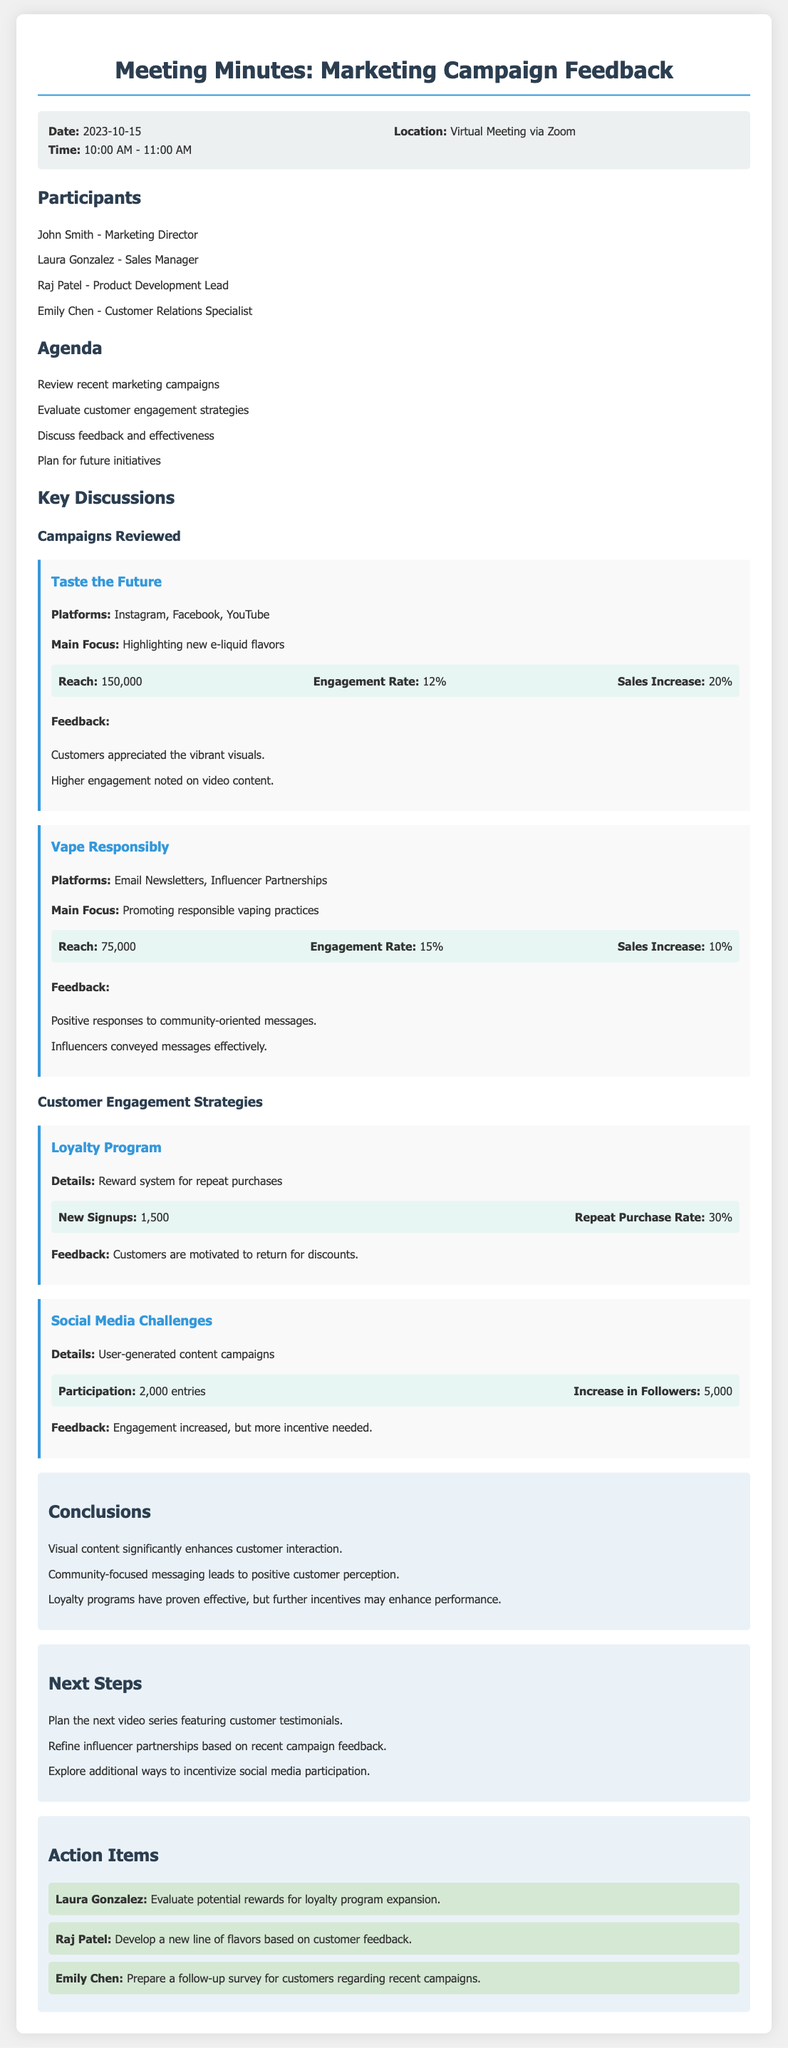What is the date of the meeting? The date of the meeting is stated at the beginning of the document.
Answer: 2023-10-15 Who is the Marketing Director? The name of the Marketing Director is listed in the participants section.
Answer: John Smith What was the engagement rate of the "Taste the Future" campaign? The engagement rate is provided in the results section of the campaign.
Answer: 12% How many new signups did the Loyalty Program gain? The number of new signups is mentioned in the results section of the strategy.
Answer: 1,500 What are the next steps planned for the video series? The next step regarding video series is specified in the next steps section of the document.
Answer: Plan the next video series featuring customer testimonials What feedback was given for the "Vape Responsibly" campaign? The feedback is summarized in the feedback section of the campaign.
Answer: Positive responses to community-oriented messages How many entries were there in the Social Media Challenges? The total number of entries is listed in the results section of the strategy.
Answer: 2,000 What action item is assigned to Laura Gonzalez? The action item for Laura Gonzalez is recorded in the action items section.
Answer: Evaluate potential rewards for loyalty program expansion 